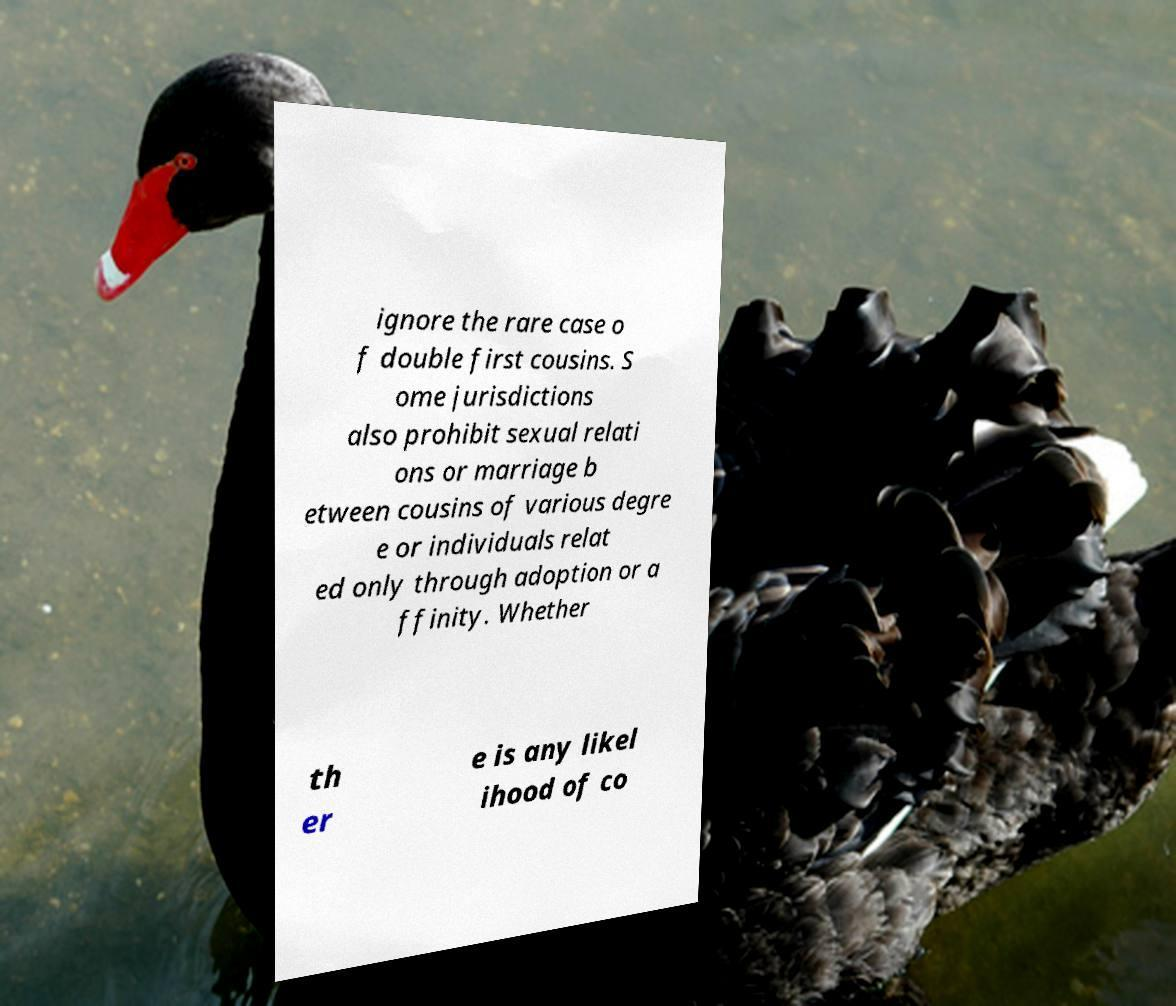Could you extract and type out the text from this image? ignore the rare case o f double first cousins. S ome jurisdictions also prohibit sexual relati ons or marriage b etween cousins of various degre e or individuals relat ed only through adoption or a ffinity. Whether th er e is any likel ihood of co 